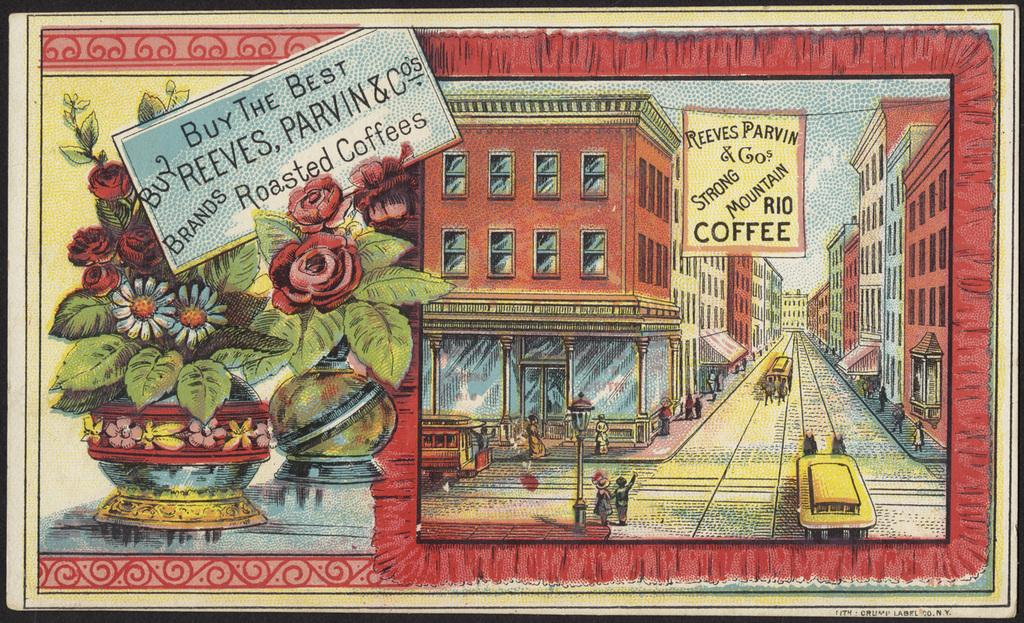What is the main subject of the painted board in the image? The painted board contains images of flower vases, buildings, people, and texted papers. Can you describe the images of flower vases on the painted board? The painted board contains images of flower vases. What other types of images are present on the painted board? There are images of buildings and people on the painted board. Are there any written elements on the painted board? Yes, there are texted papers depicted on the painted board. Where is the lock located on the painted board? There is no lock present on the painted board; it only contains images of flower vases, buildings, people, and texted papers. 